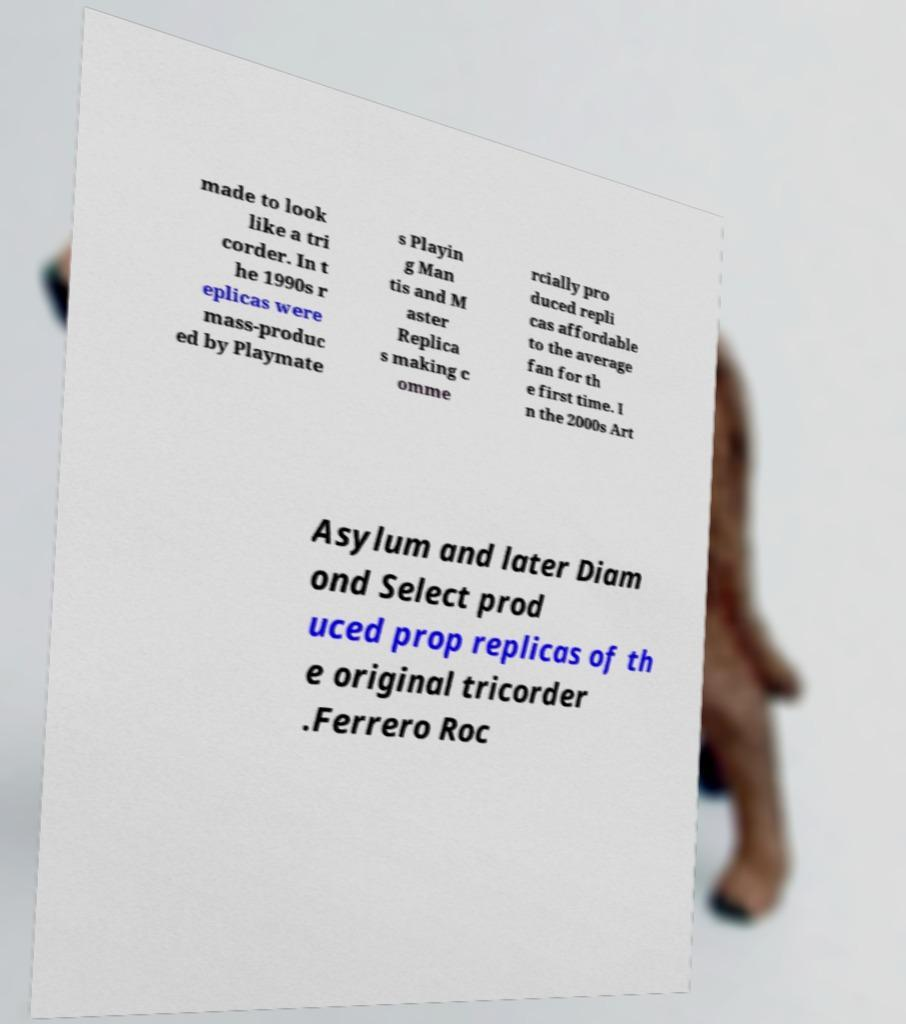Please identify and transcribe the text found in this image. made to look like a tri corder. In t he 1990s r eplicas were mass-produc ed by Playmate s Playin g Man tis and M aster Replica s making c omme rcially pro duced repli cas affordable to the average fan for th e first time. I n the 2000s Art Asylum and later Diam ond Select prod uced prop replicas of th e original tricorder .Ferrero Roc 